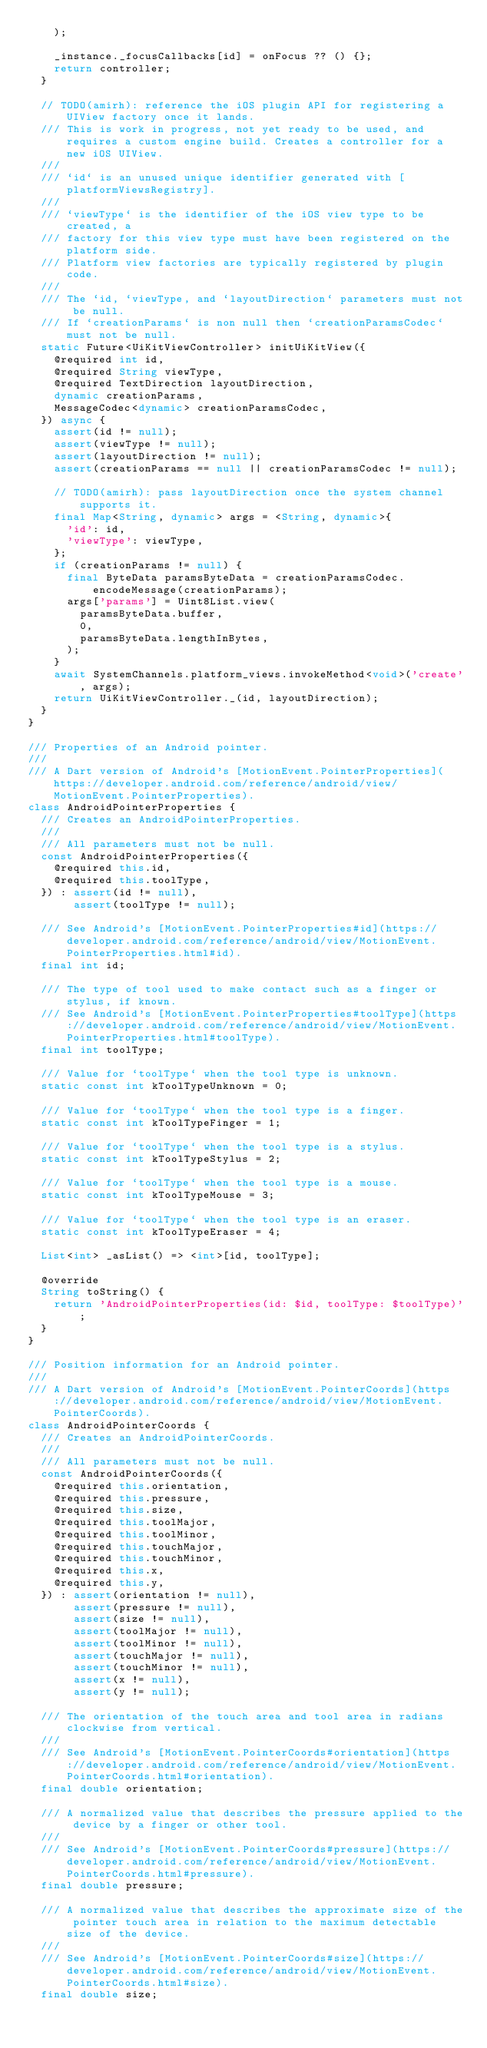<code> <loc_0><loc_0><loc_500><loc_500><_Dart_>    );

    _instance._focusCallbacks[id] = onFocus ?? () {};
    return controller;
  }

  // TODO(amirh): reference the iOS plugin API for registering a UIView factory once it lands.
  /// This is work in progress, not yet ready to be used, and requires a custom engine build. Creates a controller for a new iOS UIView.
  ///
  /// `id` is an unused unique identifier generated with [platformViewsRegistry].
  ///
  /// `viewType` is the identifier of the iOS view type to be created, a
  /// factory for this view type must have been registered on the platform side.
  /// Platform view factories are typically registered by plugin code.
  ///
  /// The `id, `viewType, and `layoutDirection` parameters must not be null.
  /// If `creationParams` is non null then `creationParamsCodec` must not be null.
  static Future<UiKitViewController> initUiKitView({
    @required int id,
    @required String viewType,
    @required TextDirection layoutDirection,
    dynamic creationParams,
    MessageCodec<dynamic> creationParamsCodec,
  }) async {
    assert(id != null);
    assert(viewType != null);
    assert(layoutDirection != null);
    assert(creationParams == null || creationParamsCodec != null);

    // TODO(amirh): pass layoutDirection once the system channel supports it.
    final Map<String, dynamic> args = <String, dynamic>{
      'id': id,
      'viewType': viewType,
    };
    if (creationParams != null) {
      final ByteData paramsByteData = creationParamsCodec.encodeMessage(creationParams);
      args['params'] = Uint8List.view(
        paramsByteData.buffer,
        0,
        paramsByteData.lengthInBytes,
      );
    }
    await SystemChannels.platform_views.invokeMethod<void>('create', args);
    return UiKitViewController._(id, layoutDirection);
  }
}

/// Properties of an Android pointer.
///
/// A Dart version of Android's [MotionEvent.PointerProperties](https://developer.android.com/reference/android/view/MotionEvent.PointerProperties).
class AndroidPointerProperties {
  /// Creates an AndroidPointerProperties.
  ///
  /// All parameters must not be null.
  const AndroidPointerProperties({
    @required this.id,
    @required this.toolType,
  }) : assert(id != null),
       assert(toolType != null);

  /// See Android's [MotionEvent.PointerProperties#id](https://developer.android.com/reference/android/view/MotionEvent.PointerProperties.html#id).
  final int id;

  /// The type of tool used to make contact such as a finger or stylus, if known.
  /// See Android's [MotionEvent.PointerProperties#toolType](https://developer.android.com/reference/android/view/MotionEvent.PointerProperties.html#toolType).
  final int toolType;

  /// Value for `toolType` when the tool type is unknown.
  static const int kToolTypeUnknown = 0;

  /// Value for `toolType` when the tool type is a finger.
  static const int kToolTypeFinger = 1;

  /// Value for `toolType` when the tool type is a stylus.
  static const int kToolTypeStylus = 2;

  /// Value for `toolType` when the tool type is a mouse.
  static const int kToolTypeMouse = 3;

  /// Value for `toolType` when the tool type is an eraser.
  static const int kToolTypeEraser = 4;

  List<int> _asList() => <int>[id, toolType];

  @override
  String toString() {
    return 'AndroidPointerProperties(id: $id, toolType: $toolType)';
  }
}

/// Position information for an Android pointer.
///
/// A Dart version of Android's [MotionEvent.PointerCoords](https://developer.android.com/reference/android/view/MotionEvent.PointerCoords).
class AndroidPointerCoords {
  /// Creates an AndroidPointerCoords.
  ///
  /// All parameters must not be null.
  const AndroidPointerCoords({
    @required this.orientation,
    @required this.pressure,
    @required this.size,
    @required this.toolMajor,
    @required this.toolMinor,
    @required this.touchMajor,
    @required this.touchMinor,
    @required this.x,
    @required this.y,
  }) : assert(orientation != null),
       assert(pressure != null),
       assert(size != null),
       assert(toolMajor != null),
       assert(toolMinor != null),
       assert(touchMajor != null),
       assert(touchMinor != null),
       assert(x != null),
       assert(y != null);

  /// The orientation of the touch area and tool area in radians clockwise from vertical.
  ///
  /// See Android's [MotionEvent.PointerCoords#orientation](https://developer.android.com/reference/android/view/MotionEvent.PointerCoords.html#orientation).
  final double orientation;

  /// A normalized value that describes the pressure applied to the device by a finger or other tool.
  ///
  /// See Android's [MotionEvent.PointerCoords#pressure](https://developer.android.com/reference/android/view/MotionEvent.PointerCoords.html#pressure).
  final double pressure;

  /// A normalized value that describes the approximate size of the pointer touch area in relation to the maximum detectable size of the device.
  ///
  /// See Android's [MotionEvent.PointerCoords#size](https://developer.android.com/reference/android/view/MotionEvent.PointerCoords.html#size).
  final double size;
</code> 